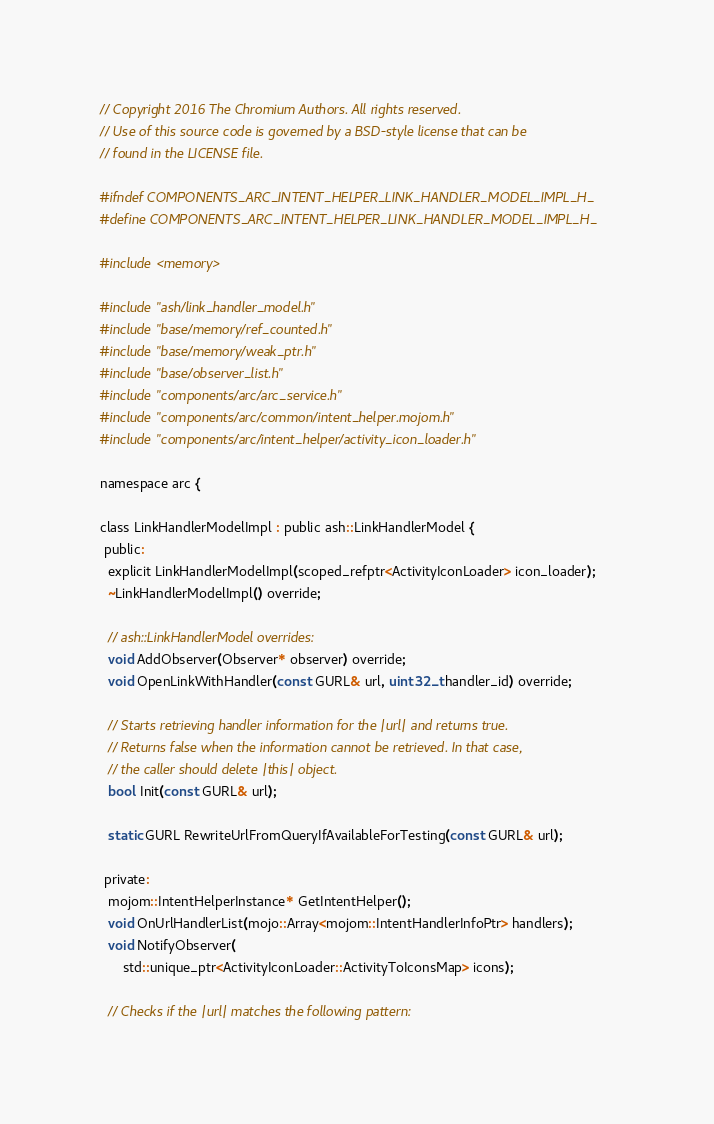Convert code to text. <code><loc_0><loc_0><loc_500><loc_500><_C_>// Copyright 2016 The Chromium Authors. All rights reserved.
// Use of this source code is governed by a BSD-style license that can be
// found in the LICENSE file.

#ifndef COMPONENTS_ARC_INTENT_HELPER_LINK_HANDLER_MODEL_IMPL_H_
#define COMPONENTS_ARC_INTENT_HELPER_LINK_HANDLER_MODEL_IMPL_H_

#include <memory>

#include "ash/link_handler_model.h"
#include "base/memory/ref_counted.h"
#include "base/memory/weak_ptr.h"
#include "base/observer_list.h"
#include "components/arc/arc_service.h"
#include "components/arc/common/intent_helper.mojom.h"
#include "components/arc/intent_helper/activity_icon_loader.h"

namespace arc {

class LinkHandlerModelImpl : public ash::LinkHandlerModel {
 public:
  explicit LinkHandlerModelImpl(scoped_refptr<ActivityIconLoader> icon_loader);
  ~LinkHandlerModelImpl() override;

  // ash::LinkHandlerModel overrides:
  void AddObserver(Observer* observer) override;
  void OpenLinkWithHandler(const GURL& url, uint32_t handler_id) override;

  // Starts retrieving handler information for the |url| and returns true.
  // Returns false when the information cannot be retrieved. In that case,
  // the caller should delete |this| object.
  bool Init(const GURL& url);

  static GURL RewriteUrlFromQueryIfAvailableForTesting(const GURL& url);

 private:
  mojom::IntentHelperInstance* GetIntentHelper();
  void OnUrlHandlerList(mojo::Array<mojom::IntentHandlerInfoPtr> handlers);
  void NotifyObserver(
      std::unique_ptr<ActivityIconLoader::ActivityToIconsMap> icons);

  // Checks if the |url| matches the following pattern:</code> 